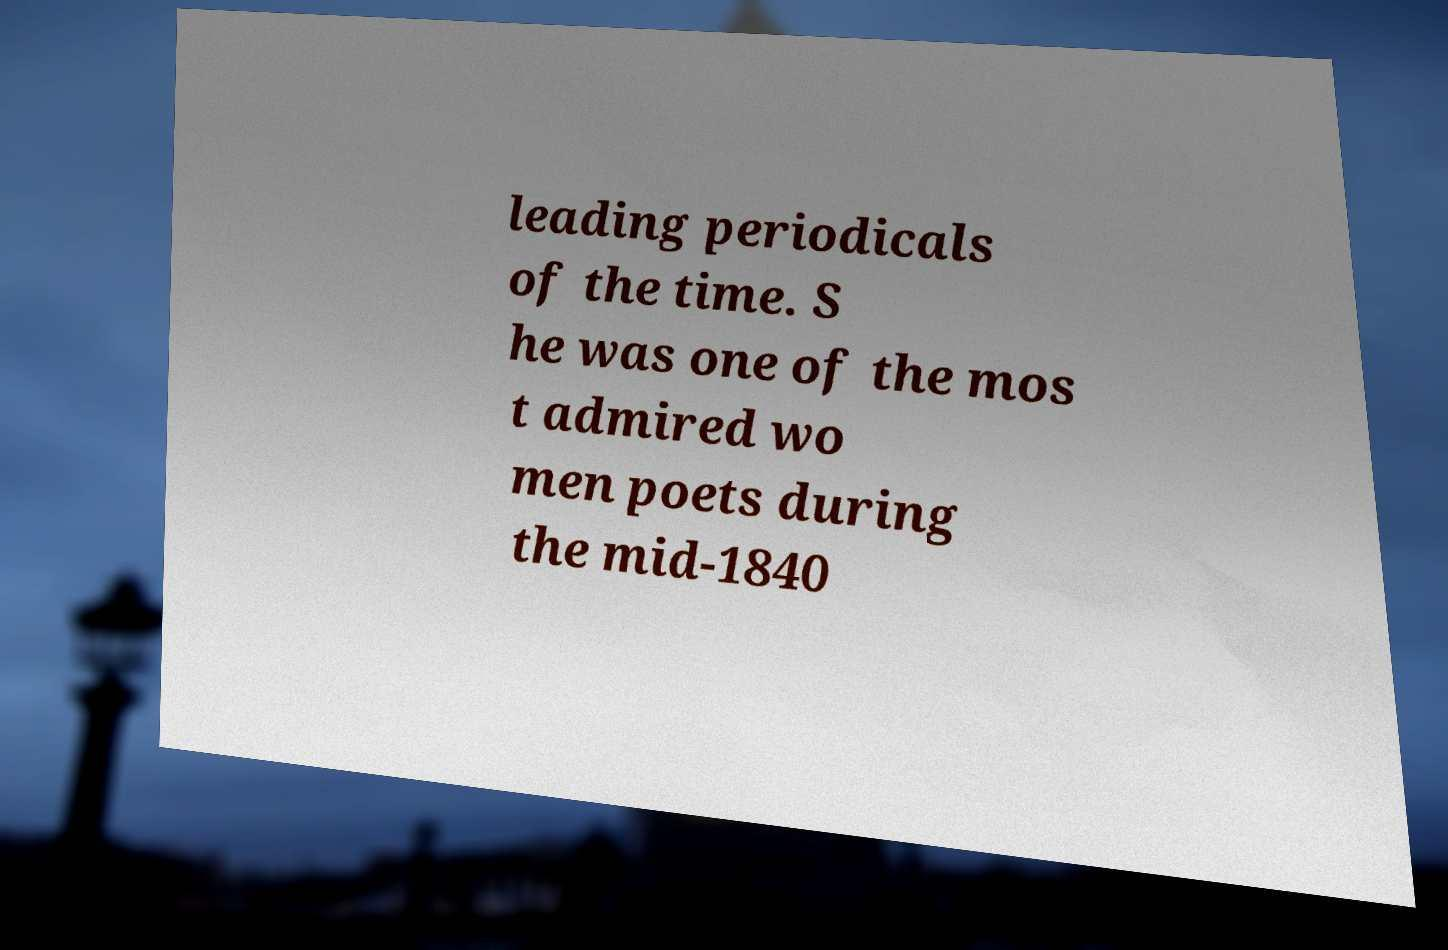There's text embedded in this image that I need extracted. Can you transcribe it verbatim? leading periodicals of the time. S he was one of the mos t admired wo men poets during the mid-1840 